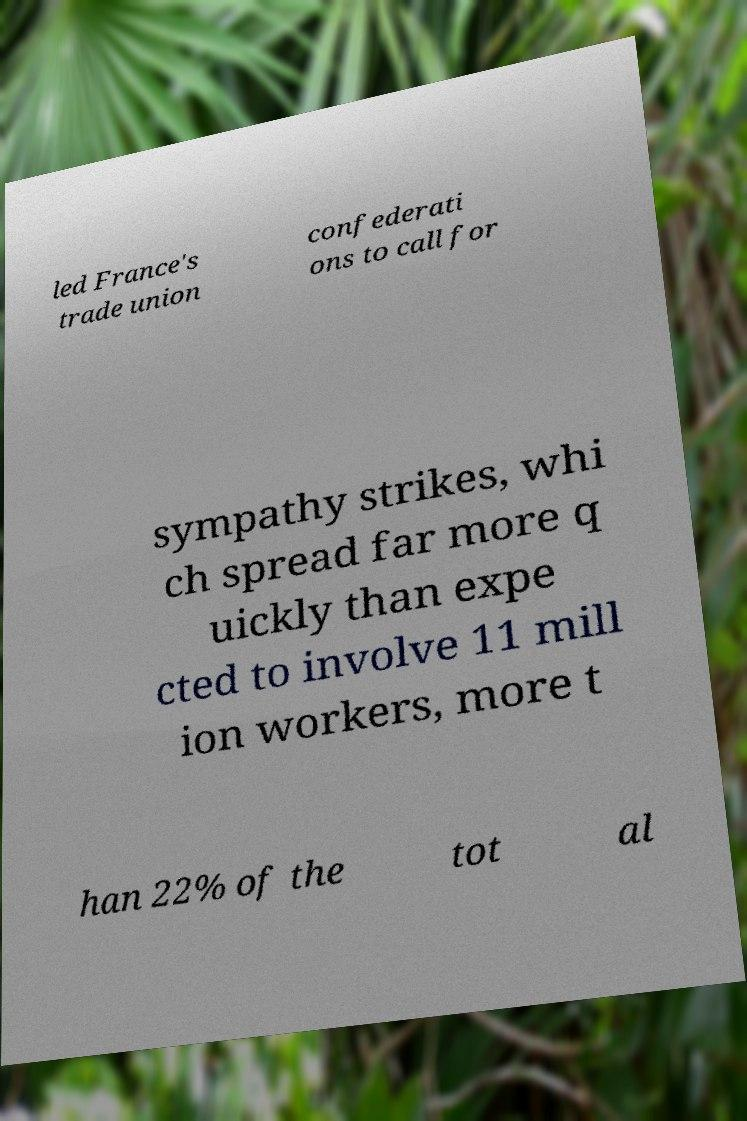Could you assist in decoding the text presented in this image and type it out clearly? led France's trade union confederati ons to call for sympathy strikes, whi ch spread far more q uickly than expe cted to involve 11 mill ion workers, more t han 22% of the tot al 